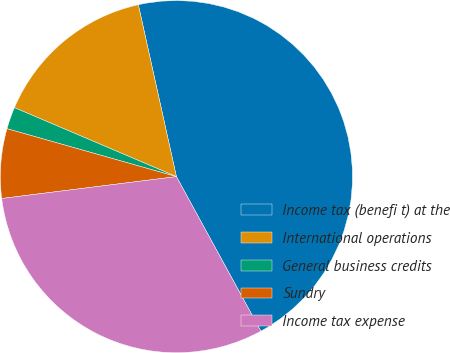Convert chart to OTSL. <chart><loc_0><loc_0><loc_500><loc_500><pie_chart><fcel>Income tax (benefi t) at the<fcel>International operations<fcel>General business credits<fcel>Sundry<fcel>Income tax expense<nl><fcel>45.51%<fcel>15.12%<fcel>2.02%<fcel>6.37%<fcel>30.98%<nl></chart> 